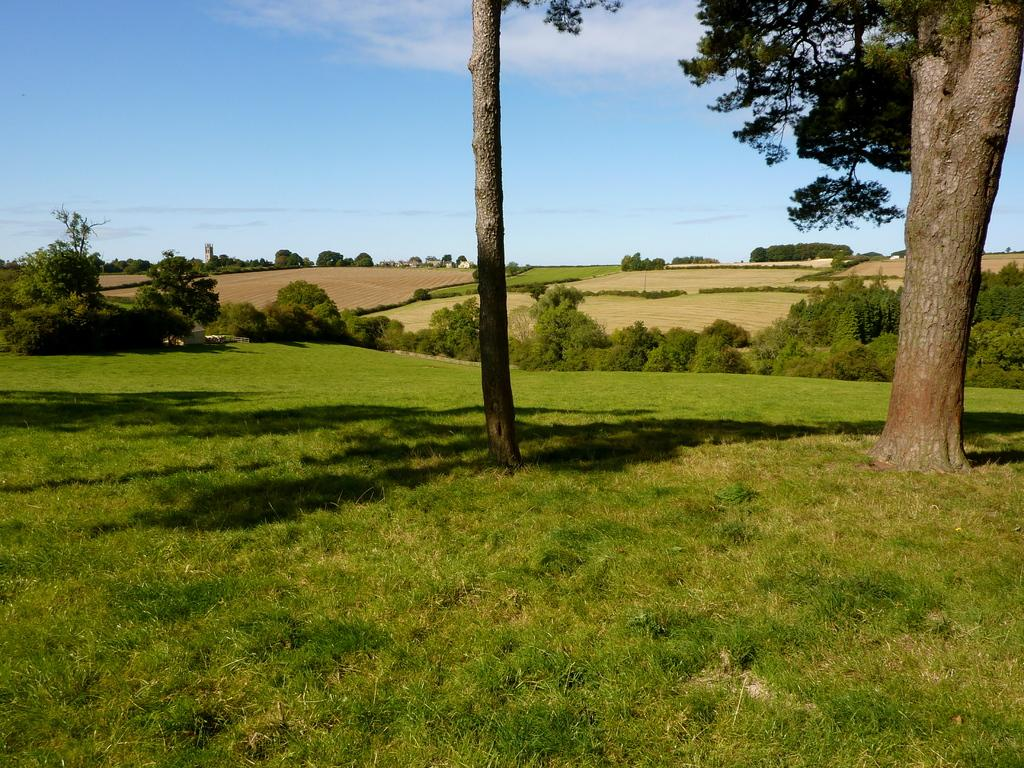What type of vegetation is in the foreground of the image? There is grass and trees in the foreground of the image. What else can be seen in the foreground of the image besides vegetation? There are no other objects or structures visible in the foreground; only grass and trees are present. What type of landscape can be seen in the background of the image? There are fields and trees in the background of the image. What is visible in the sky in the background of the image? There is sky visible in the background of the image, and there is a cloud visible in the sky. Where is the worm located in the image? There is no worm present in the image. What type of crib can be seen in the image? There is no crib present in the image. 